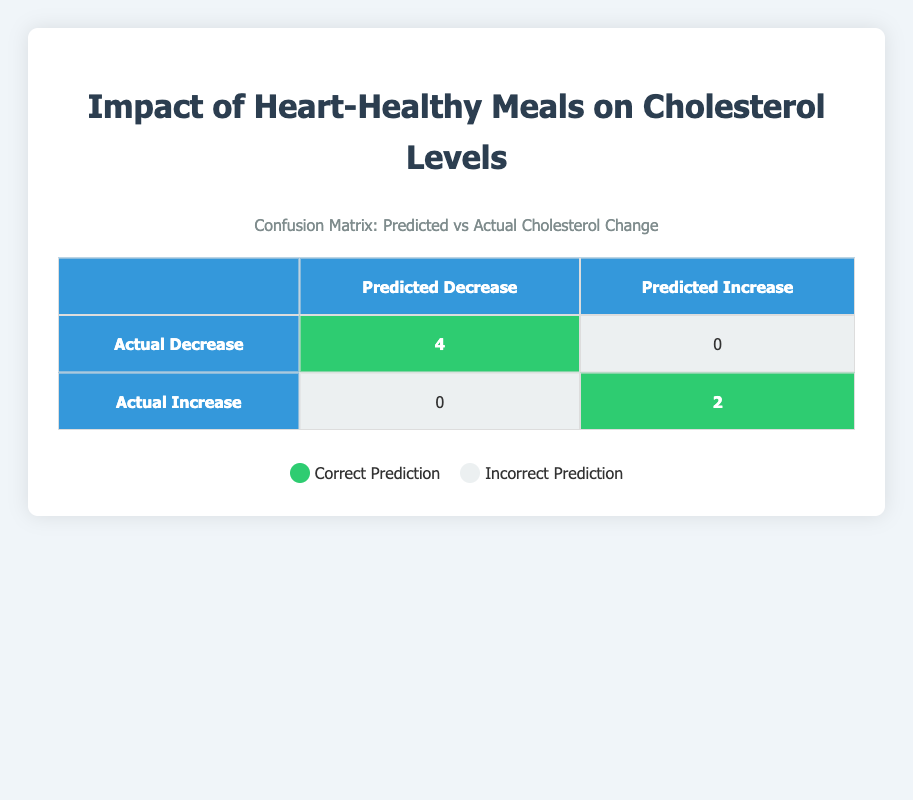What is the total number of participants who experienced a decrease in cholesterol after dietary changes? The table shows that there are 4 participants listed under "Actual Decrease," which indicates they had a cholesterol reduction post-intervention.
Answer: 4 What is the total number of participants whose cholesterol increased after the intervention? The table displays 2 participants under "Actual Increase," indicating that they saw a rise in cholesterol levels after making dietary changes.
Answer: 2 Did all participants who had a predicted decrease actually experience a decrease in cholesterol? Looking at the table, 4 participants had a predicted decrease and all of them fell under "Actual Decrease," confirming that all predicted decreases were correct.
Answer: Yes What is the predicted outcome for participants who actually had an increase in cholesterol? According to the table, all 2 participants who had an actual increase also had a predicted increase, showing a direct correlation between predicted and actual outcomes.
Answer: Predicted Increase What is the difference in the number of correct predictions between cholesterol decrease and increase? The table shows 4 correct predictions for decrease and 2 correct predictions for increase. Thus, the difference is 4 (decrease) - 2 (increase) = 2.
Answer: 2 What percentage of participants who changed their diets achieved a successful decrease in cholesterol levels? To find the percentage, we take the number of participants that had a decrease (4) and divide it by the total number of participants (6), then multiply by 100: (4/6) * 100 = 66.67%.
Answer: 66.67% How many participants had inaccurate predictions regarding their cholesterol changes? The table indicates that there were 0 participants who had an incorrect prediction for a decrease and 0 participants who had an incorrect prediction for an increase, totaling 0 inaccuracies.
Answer: 0 What can be inferred about the effectiveness of the dietary changes based on this confusion matrix? The confusion matrix illustrates that dietary changes were generally effective since the majority of participants correctly predicted to have a decrease in cholesterol, and there were no false predictions for decrease.
Answer: Effective 